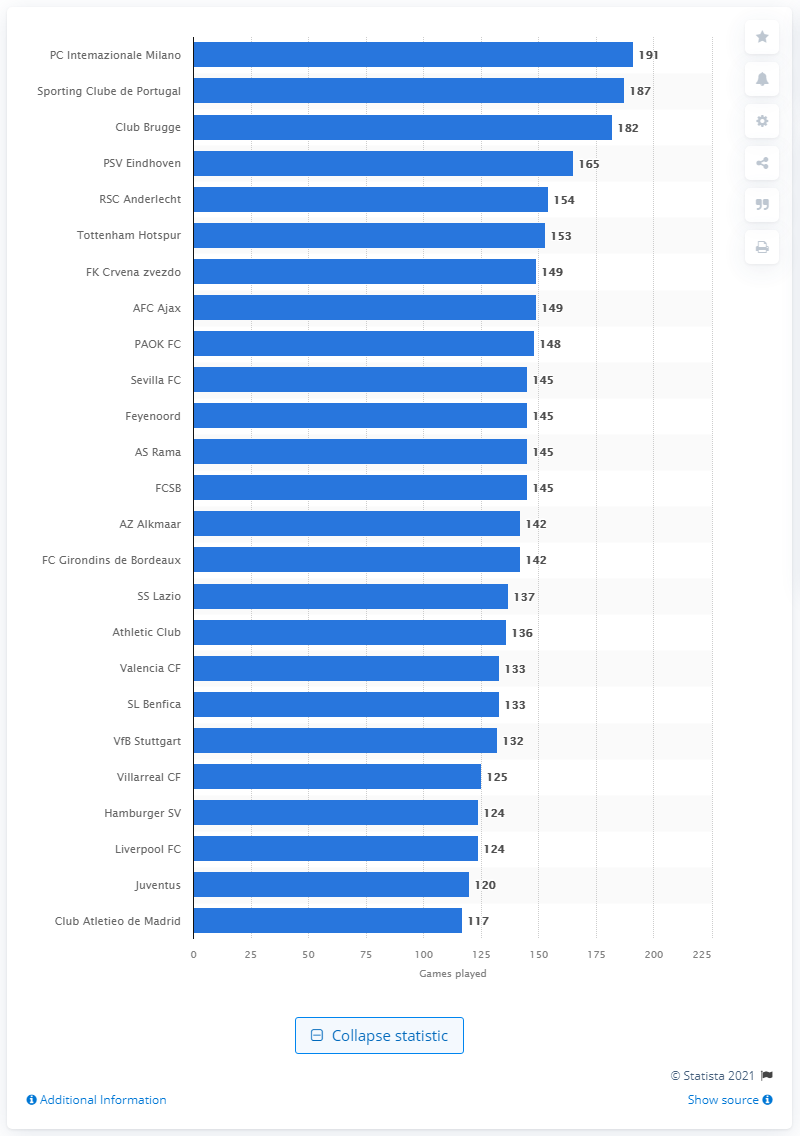Highlight a few significant elements in this photo. Inter Milan had played 191 games in the UEFA Europa League as of May 2021. The UEFA Europa League games played by Sporting Clube de Portugal as of May 2021 were 187. 